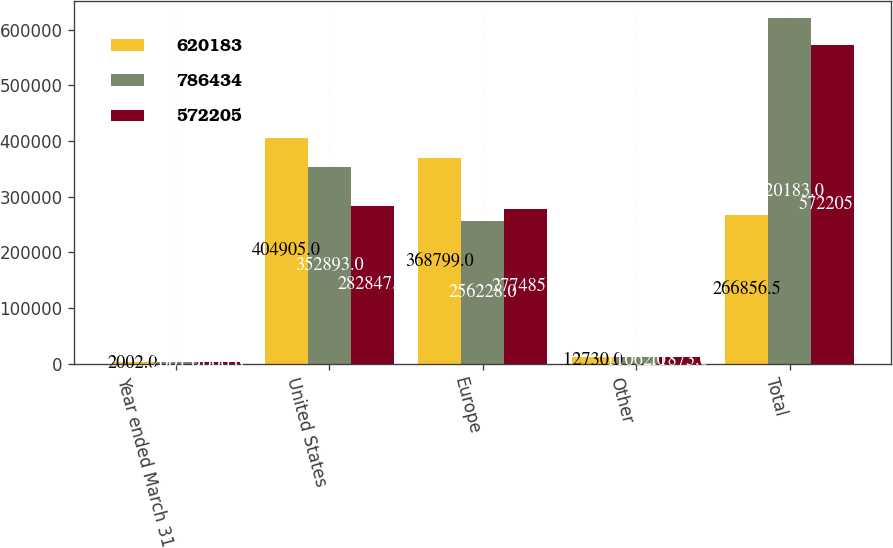Convert chart. <chart><loc_0><loc_0><loc_500><loc_500><stacked_bar_chart><ecel><fcel>Year ended March 31<fcel>United States<fcel>Europe<fcel>Other<fcel>Total<nl><fcel>620183<fcel>2002<fcel>404905<fcel>368799<fcel>12730<fcel>266856<nl><fcel>786434<fcel>2001<fcel>352893<fcel>256228<fcel>11062<fcel>620183<nl><fcel>572205<fcel>2000<fcel>282847<fcel>277485<fcel>11873<fcel>572205<nl></chart> 